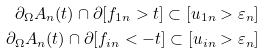Convert formula to latex. <formula><loc_0><loc_0><loc_500><loc_500>\partial _ { \Omega } A _ { n } ( t ) \cap \partial [ f _ { 1 n } > t ] \subset [ u _ { 1 n } > \varepsilon _ { n } ] \\ \partial _ { \Omega } A _ { n } ( t ) \cap \partial [ f _ { i n } < - t ] \subset [ u _ { i n } > \varepsilon _ { n } ]</formula> 